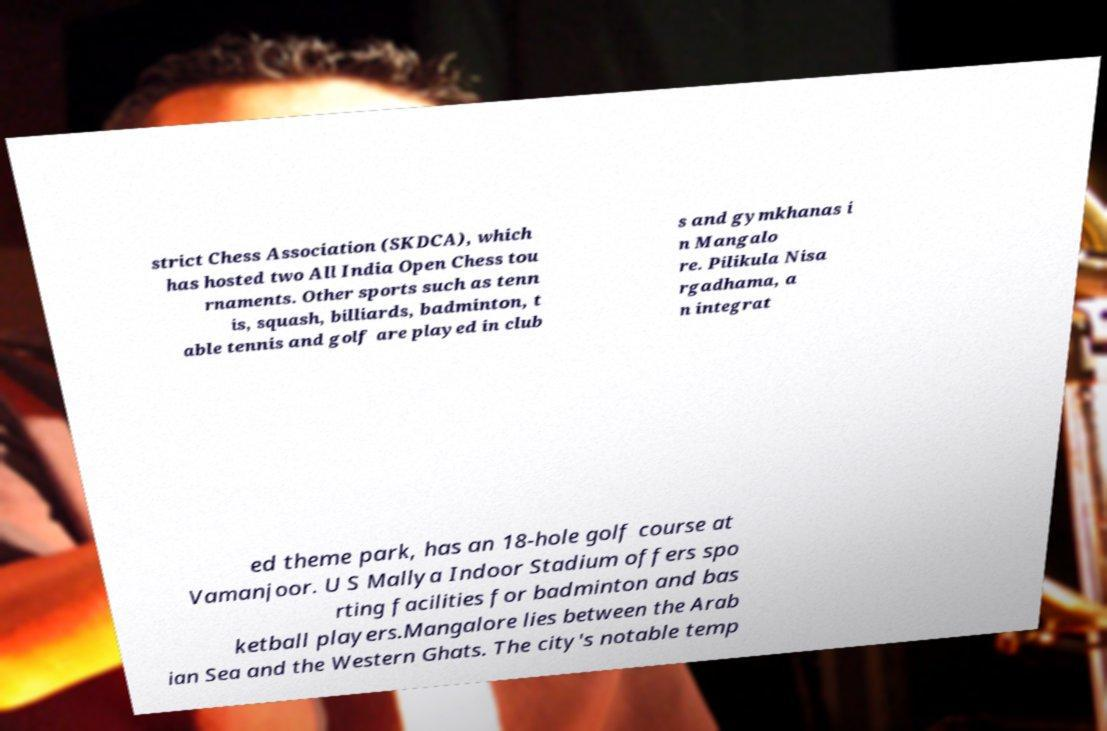There's text embedded in this image that I need extracted. Can you transcribe it verbatim? strict Chess Association (SKDCA), which has hosted two All India Open Chess tou rnaments. Other sports such as tenn is, squash, billiards, badminton, t able tennis and golf are played in club s and gymkhanas i n Mangalo re. Pilikula Nisa rgadhama, a n integrat ed theme park, has an 18-hole golf course at Vamanjoor. U S Mallya Indoor Stadium offers spo rting facilities for badminton and bas ketball players.Mangalore lies between the Arab ian Sea and the Western Ghats. The city's notable temp 